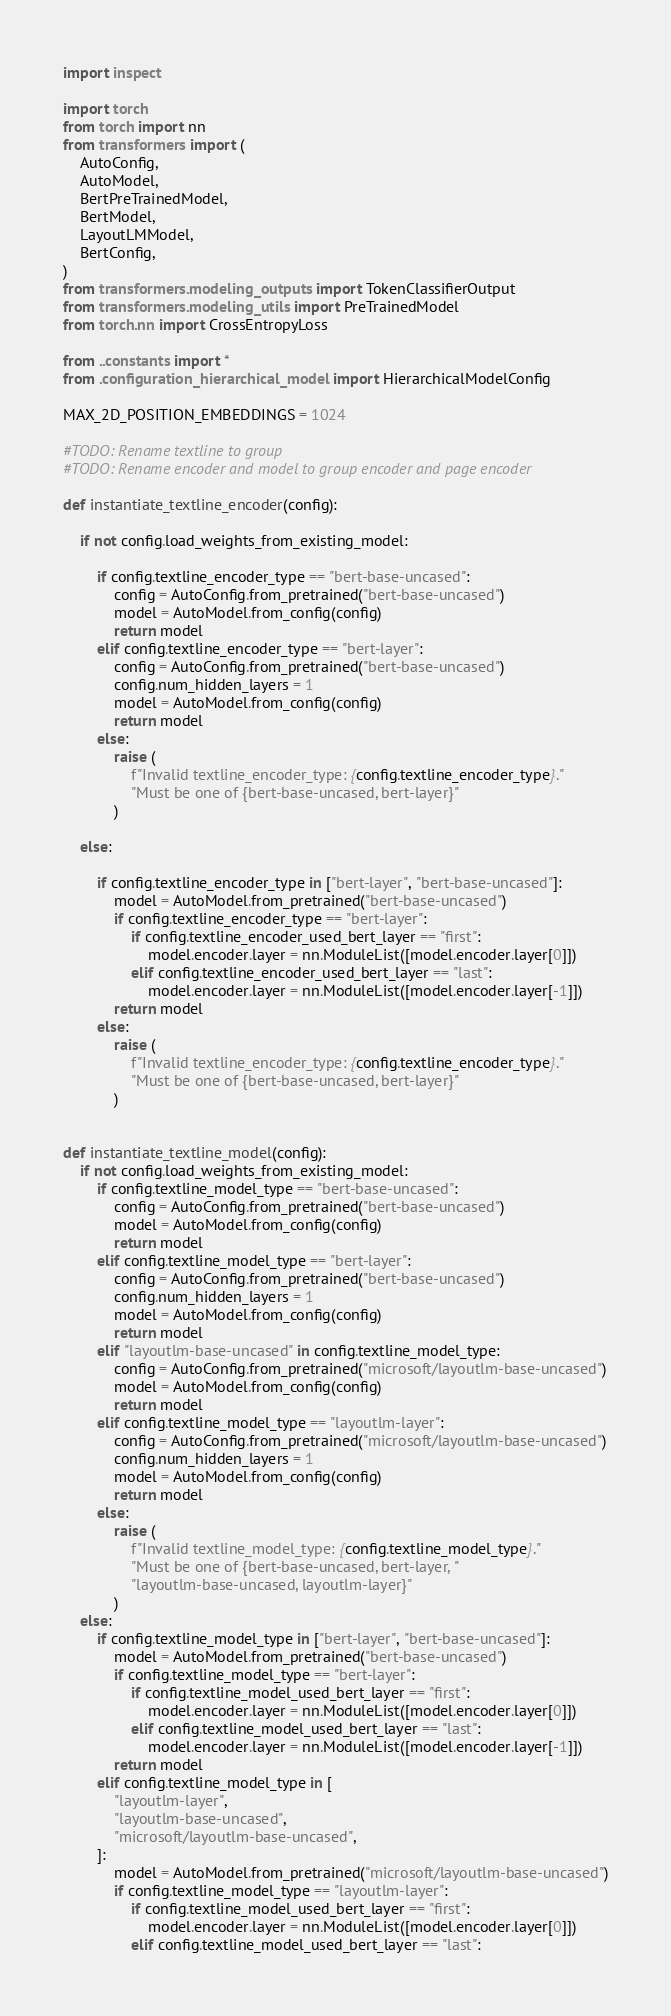Convert code to text. <code><loc_0><loc_0><loc_500><loc_500><_Python_>import inspect

import torch
from torch import nn
from transformers import (
    AutoConfig,
    AutoModel,
    BertPreTrainedModel,
    BertModel,
    LayoutLMModel,
    BertConfig,
)
from transformers.modeling_outputs import TokenClassifierOutput
from transformers.modeling_utils import PreTrainedModel
from torch.nn import CrossEntropyLoss

from ..constants import *
from .configuration_hierarchical_model import HierarchicalModelConfig

MAX_2D_POSITION_EMBEDDINGS = 1024

#TODO: Rename textline to group 
#TODO: Rename encoder and model to group encoder and page encoder 

def instantiate_textline_encoder(config):

    if not config.load_weights_from_existing_model:

        if config.textline_encoder_type == "bert-base-uncased":
            config = AutoConfig.from_pretrained("bert-base-uncased")
            model = AutoModel.from_config(config)
            return model
        elif config.textline_encoder_type == "bert-layer":
            config = AutoConfig.from_pretrained("bert-base-uncased")
            config.num_hidden_layers = 1
            model = AutoModel.from_config(config)
            return model
        else:
            raise (
                f"Invalid textline_encoder_type: {config.textline_encoder_type}."
                "Must be one of {bert-base-uncased, bert-layer}"
            )

    else:

        if config.textline_encoder_type in ["bert-layer", "bert-base-uncased"]:
            model = AutoModel.from_pretrained("bert-base-uncased")
            if config.textline_encoder_type == "bert-layer":
                if config.textline_encoder_used_bert_layer == "first":
                    model.encoder.layer = nn.ModuleList([model.encoder.layer[0]])
                elif config.textline_encoder_used_bert_layer == "last":
                    model.encoder.layer = nn.ModuleList([model.encoder.layer[-1]])
            return model
        else:
            raise (
                f"Invalid textline_encoder_type: {config.textline_encoder_type}."
                "Must be one of {bert-base-uncased, bert-layer}"
            )


def instantiate_textline_model(config):
    if not config.load_weights_from_existing_model:
        if config.textline_model_type == "bert-base-uncased":
            config = AutoConfig.from_pretrained("bert-base-uncased")
            model = AutoModel.from_config(config)
            return model
        elif config.textline_model_type == "bert-layer":
            config = AutoConfig.from_pretrained("bert-base-uncased")
            config.num_hidden_layers = 1
            model = AutoModel.from_config(config)
            return model
        elif "layoutlm-base-uncased" in config.textline_model_type:
            config = AutoConfig.from_pretrained("microsoft/layoutlm-base-uncased")
            model = AutoModel.from_config(config)
            return model
        elif config.textline_model_type == "layoutlm-layer":
            config = AutoConfig.from_pretrained("microsoft/layoutlm-base-uncased")
            config.num_hidden_layers = 1
            model = AutoModel.from_config(config)
            return model
        else:
            raise (
                f"Invalid textline_model_type: {config.textline_model_type}."
                "Must be one of {bert-base-uncased, bert-layer, "
                "layoutlm-base-uncased, layoutlm-layer}"
            )
    else:
        if config.textline_model_type in ["bert-layer", "bert-base-uncased"]:
            model = AutoModel.from_pretrained("bert-base-uncased")
            if config.textline_model_type == "bert-layer":
                if config.textline_model_used_bert_layer == "first":
                    model.encoder.layer = nn.ModuleList([model.encoder.layer[0]])
                elif config.textline_model_used_bert_layer == "last":
                    model.encoder.layer = nn.ModuleList([model.encoder.layer[-1]])
            return model
        elif config.textline_model_type in [
            "layoutlm-layer",
            "layoutlm-base-uncased",
            "microsoft/layoutlm-base-uncased",
        ]:
            model = AutoModel.from_pretrained("microsoft/layoutlm-base-uncased")
            if config.textline_model_type == "layoutlm-layer":
                if config.textline_model_used_bert_layer == "first":
                    model.encoder.layer = nn.ModuleList([model.encoder.layer[0]])
                elif config.textline_model_used_bert_layer == "last":</code> 